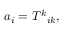<formula> <loc_0><loc_0><loc_500><loc_500>a _ { i } = T ^ { k _ { i k } ,</formula> 